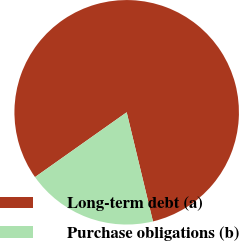Convert chart to OTSL. <chart><loc_0><loc_0><loc_500><loc_500><pie_chart><fcel>Long-term debt (a)<fcel>Purchase obligations (b)<nl><fcel>81.03%<fcel>18.97%<nl></chart> 